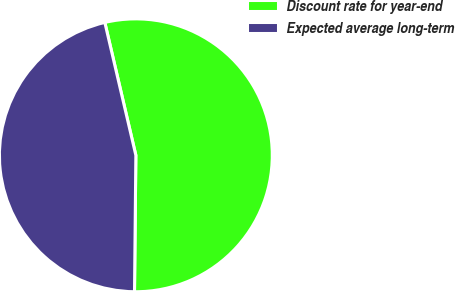<chart> <loc_0><loc_0><loc_500><loc_500><pie_chart><fcel>Discount rate for year-end<fcel>Expected average long-term<nl><fcel>53.81%<fcel>46.19%<nl></chart> 